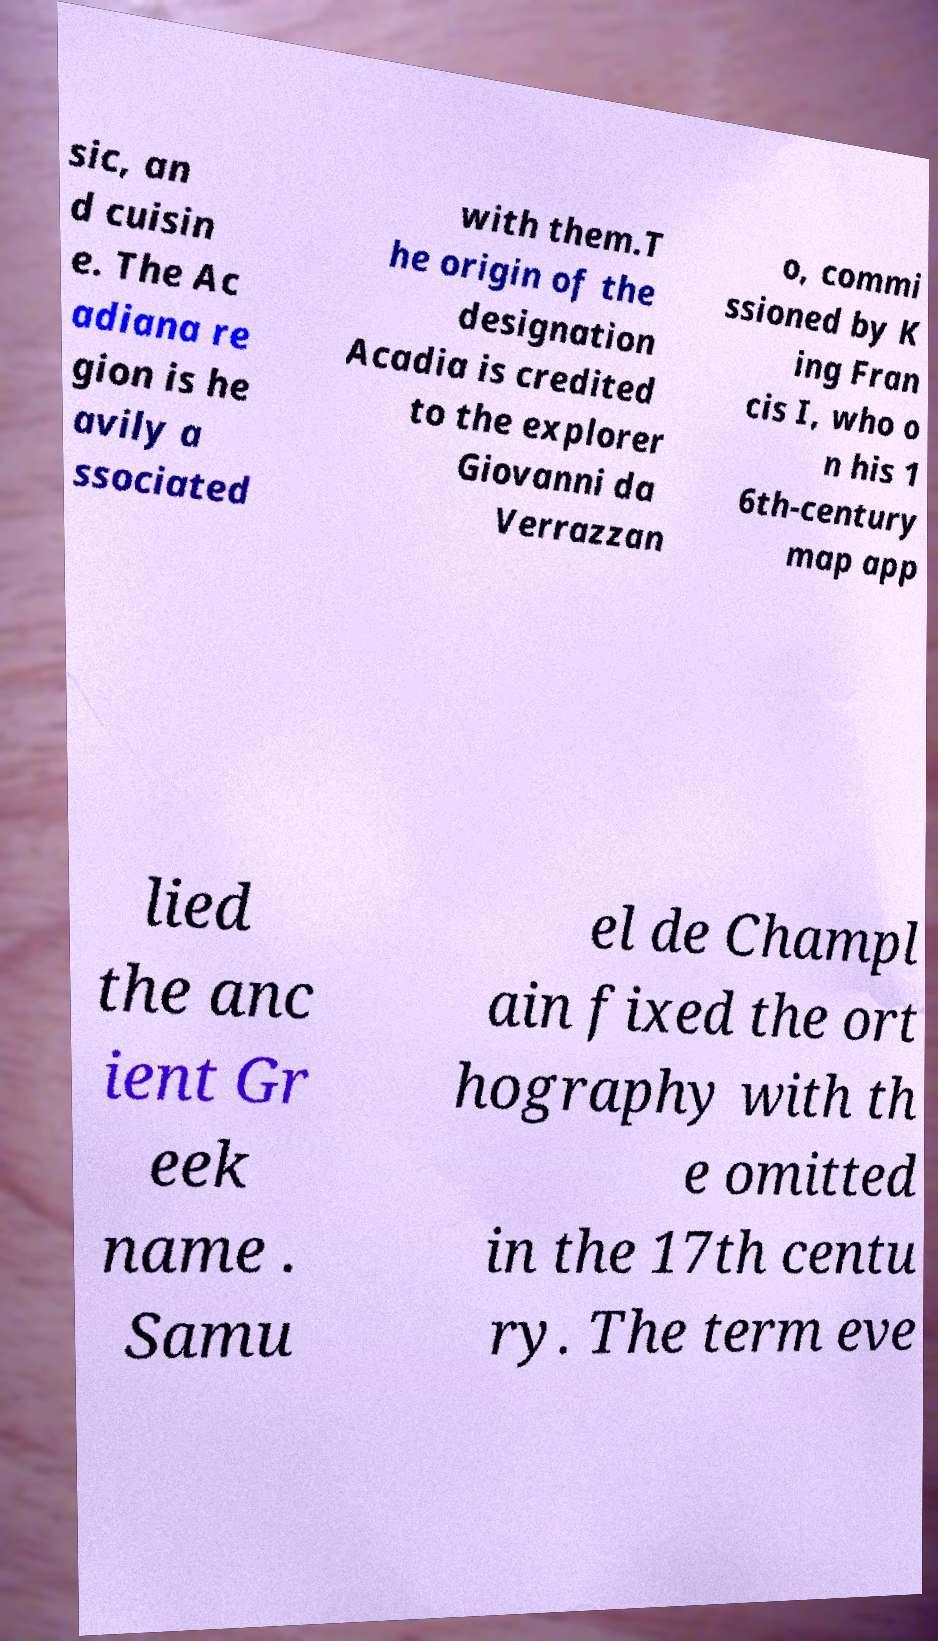Can you read and provide the text displayed in the image?This photo seems to have some interesting text. Can you extract and type it out for me? sic, an d cuisin e. The Ac adiana re gion is he avily a ssociated with them.T he origin of the designation Acadia is credited to the explorer Giovanni da Verrazzan o, commi ssioned by K ing Fran cis I, who o n his 1 6th-century map app lied the anc ient Gr eek name . Samu el de Champl ain fixed the ort hography with th e omitted in the 17th centu ry. The term eve 